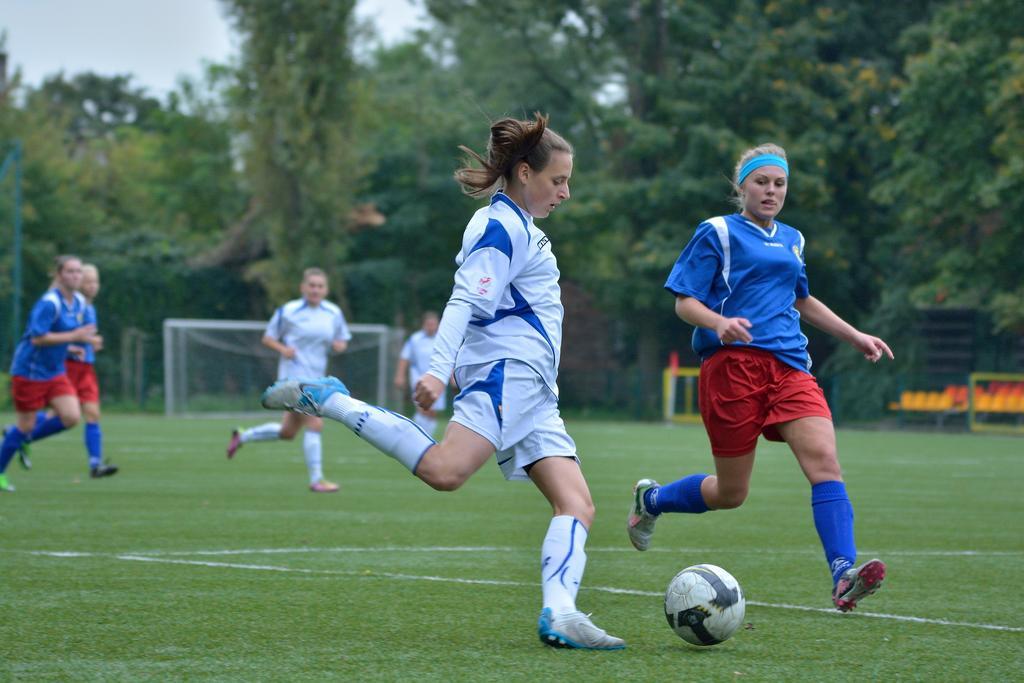Can you describe this image briefly? In the picture we can see a playground with a grass surface on it, we can see some people are playing football and they are wearing a sportswear and in the background, we can see a net and trees, plants behind it, and we can also see a sky. 